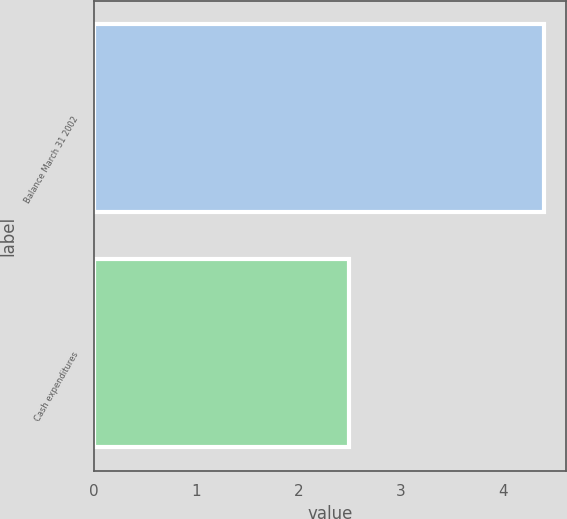<chart> <loc_0><loc_0><loc_500><loc_500><bar_chart><fcel>Balance March 31 2002<fcel>Cash expenditures<nl><fcel>4.4<fcel>2.5<nl></chart> 